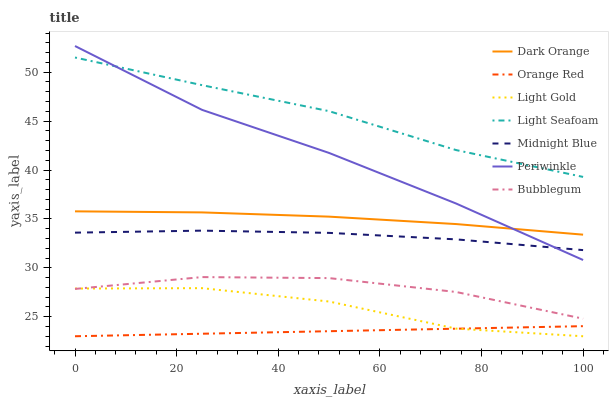Does Orange Red have the minimum area under the curve?
Answer yes or no. Yes. Does Light Seafoam have the maximum area under the curve?
Answer yes or no. Yes. Does Midnight Blue have the minimum area under the curve?
Answer yes or no. No. Does Midnight Blue have the maximum area under the curve?
Answer yes or no. No. Is Orange Red the smoothest?
Answer yes or no. Yes. Is Light Gold the roughest?
Answer yes or no. Yes. Is Midnight Blue the smoothest?
Answer yes or no. No. Is Midnight Blue the roughest?
Answer yes or no. No. Does Light Gold have the lowest value?
Answer yes or no. Yes. Does Midnight Blue have the lowest value?
Answer yes or no. No. Does Periwinkle have the highest value?
Answer yes or no. Yes. Does Midnight Blue have the highest value?
Answer yes or no. No. Is Bubblegum less than Midnight Blue?
Answer yes or no. Yes. Is Bubblegum greater than Orange Red?
Answer yes or no. Yes. Does Light Gold intersect Orange Red?
Answer yes or no. Yes. Is Light Gold less than Orange Red?
Answer yes or no. No. Is Light Gold greater than Orange Red?
Answer yes or no. No. Does Bubblegum intersect Midnight Blue?
Answer yes or no. No. 